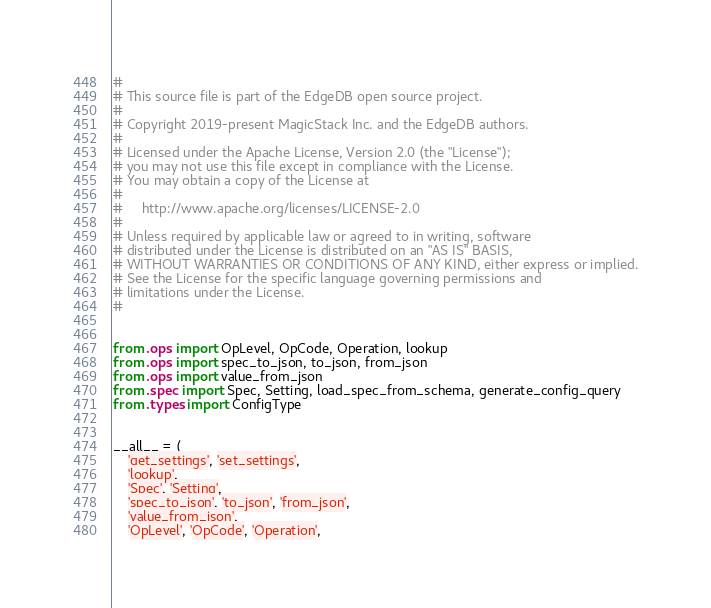<code> <loc_0><loc_0><loc_500><loc_500><_Python_>#
# This source file is part of the EdgeDB open source project.
#
# Copyright 2019-present MagicStack Inc. and the EdgeDB authors.
#
# Licensed under the Apache License, Version 2.0 (the "License");
# you may not use this file except in compliance with the License.
# You may obtain a copy of the License at
#
#     http://www.apache.org/licenses/LICENSE-2.0
#
# Unless required by applicable law or agreed to in writing, software
# distributed under the License is distributed on an "AS IS" BASIS,
# WITHOUT WARRANTIES OR CONDITIONS OF ANY KIND, either express or implied.
# See the License for the specific language governing permissions and
# limitations under the License.
#


from .ops import OpLevel, OpCode, Operation, lookup
from .ops import spec_to_json, to_json, from_json
from .ops import value_from_json
from .spec import Spec, Setting, load_spec_from_schema, generate_config_query
from .types import ConfigType


__all__ = (
    'get_settings', 'set_settings',
    'lookup',
    'Spec', 'Setting',
    'spec_to_json', 'to_json', 'from_json',
    'value_from_json',
    'OpLevel', 'OpCode', 'Operation',</code> 